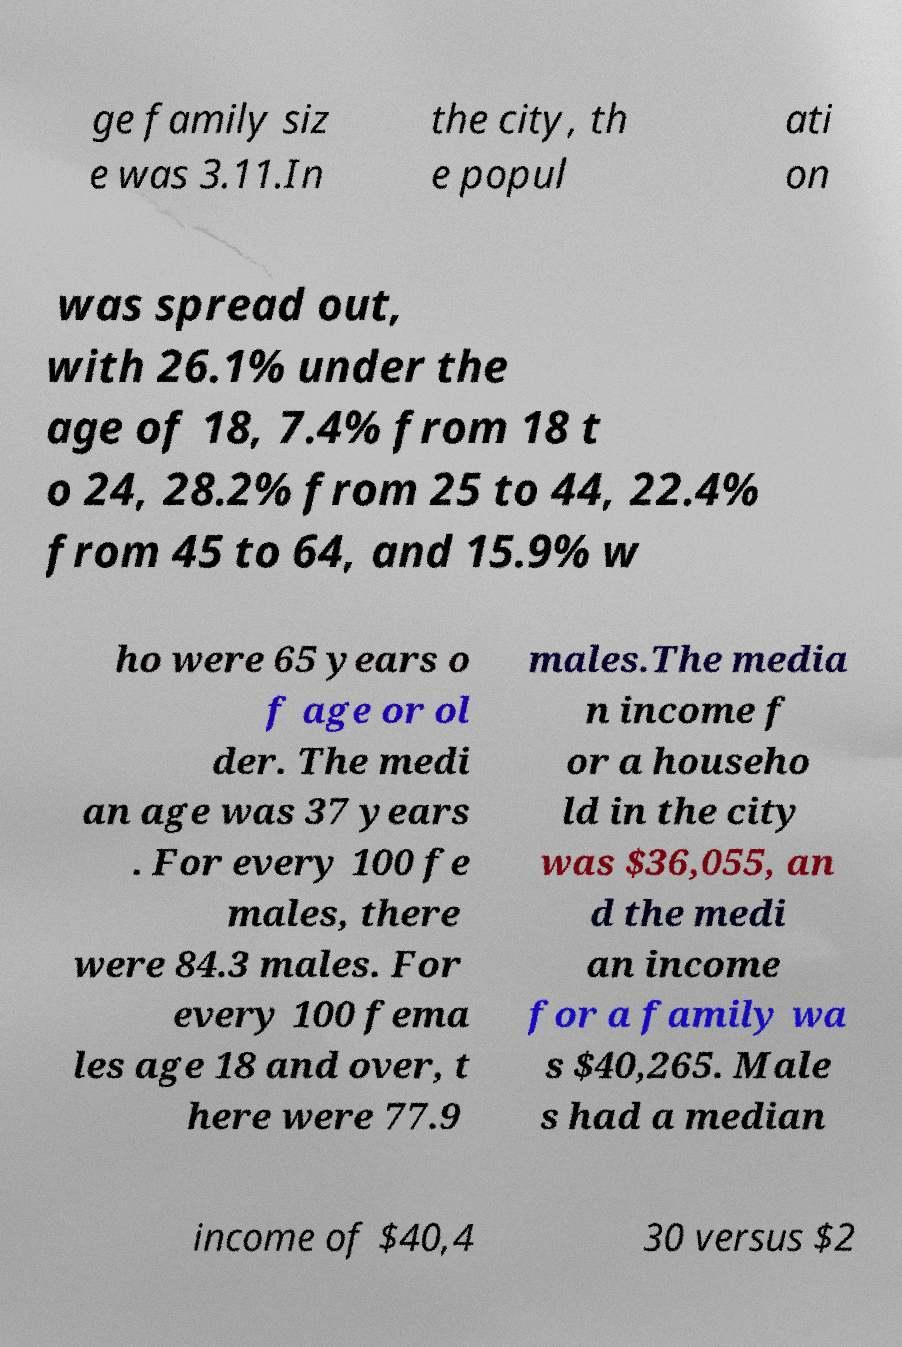Can you accurately transcribe the text from the provided image for me? ge family siz e was 3.11.In the city, th e popul ati on was spread out, with 26.1% under the age of 18, 7.4% from 18 t o 24, 28.2% from 25 to 44, 22.4% from 45 to 64, and 15.9% w ho were 65 years o f age or ol der. The medi an age was 37 years . For every 100 fe males, there were 84.3 males. For every 100 fema les age 18 and over, t here were 77.9 males.The media n income f or a househo ld in the city was $36,055, an d the medi an income for a family wa s $40,265. Male s had a median income of $40,4 30 versus $2 